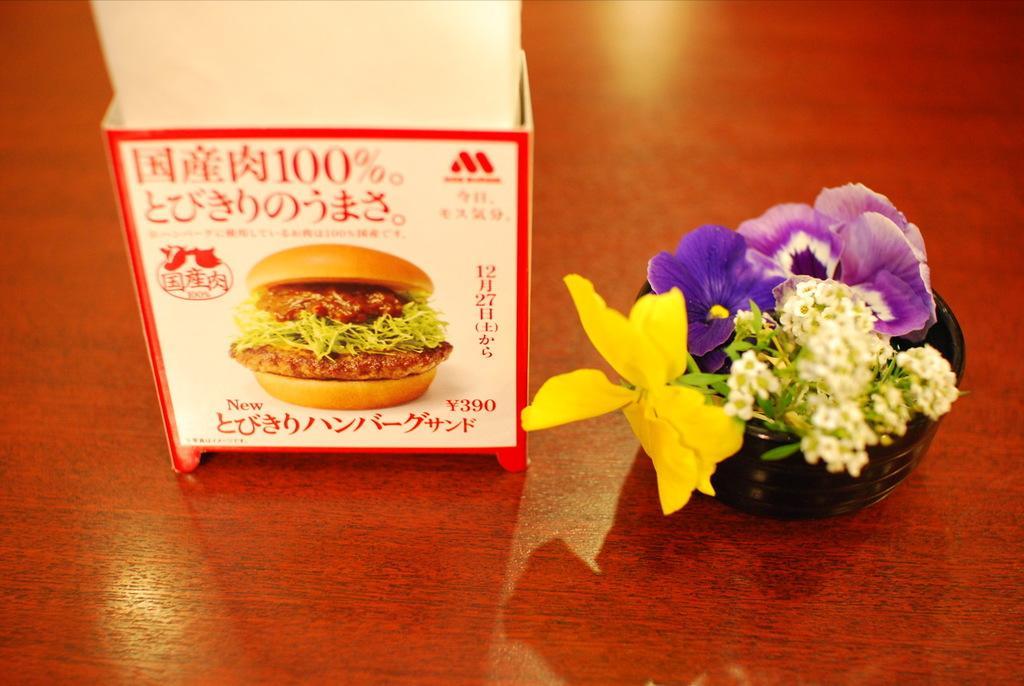Could you give a brief overview of what you see in this image? In the image we can see there is a tissue paper box kept on the table on which there is a burger drawn on it. Beside there is a small vase in which there are flowers kept on the table. 